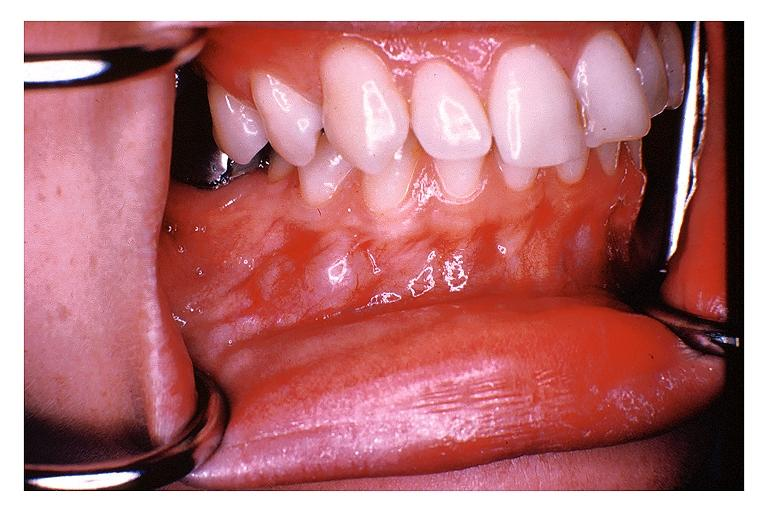what is present?
Answer the question using a single word or phrase. Oral 